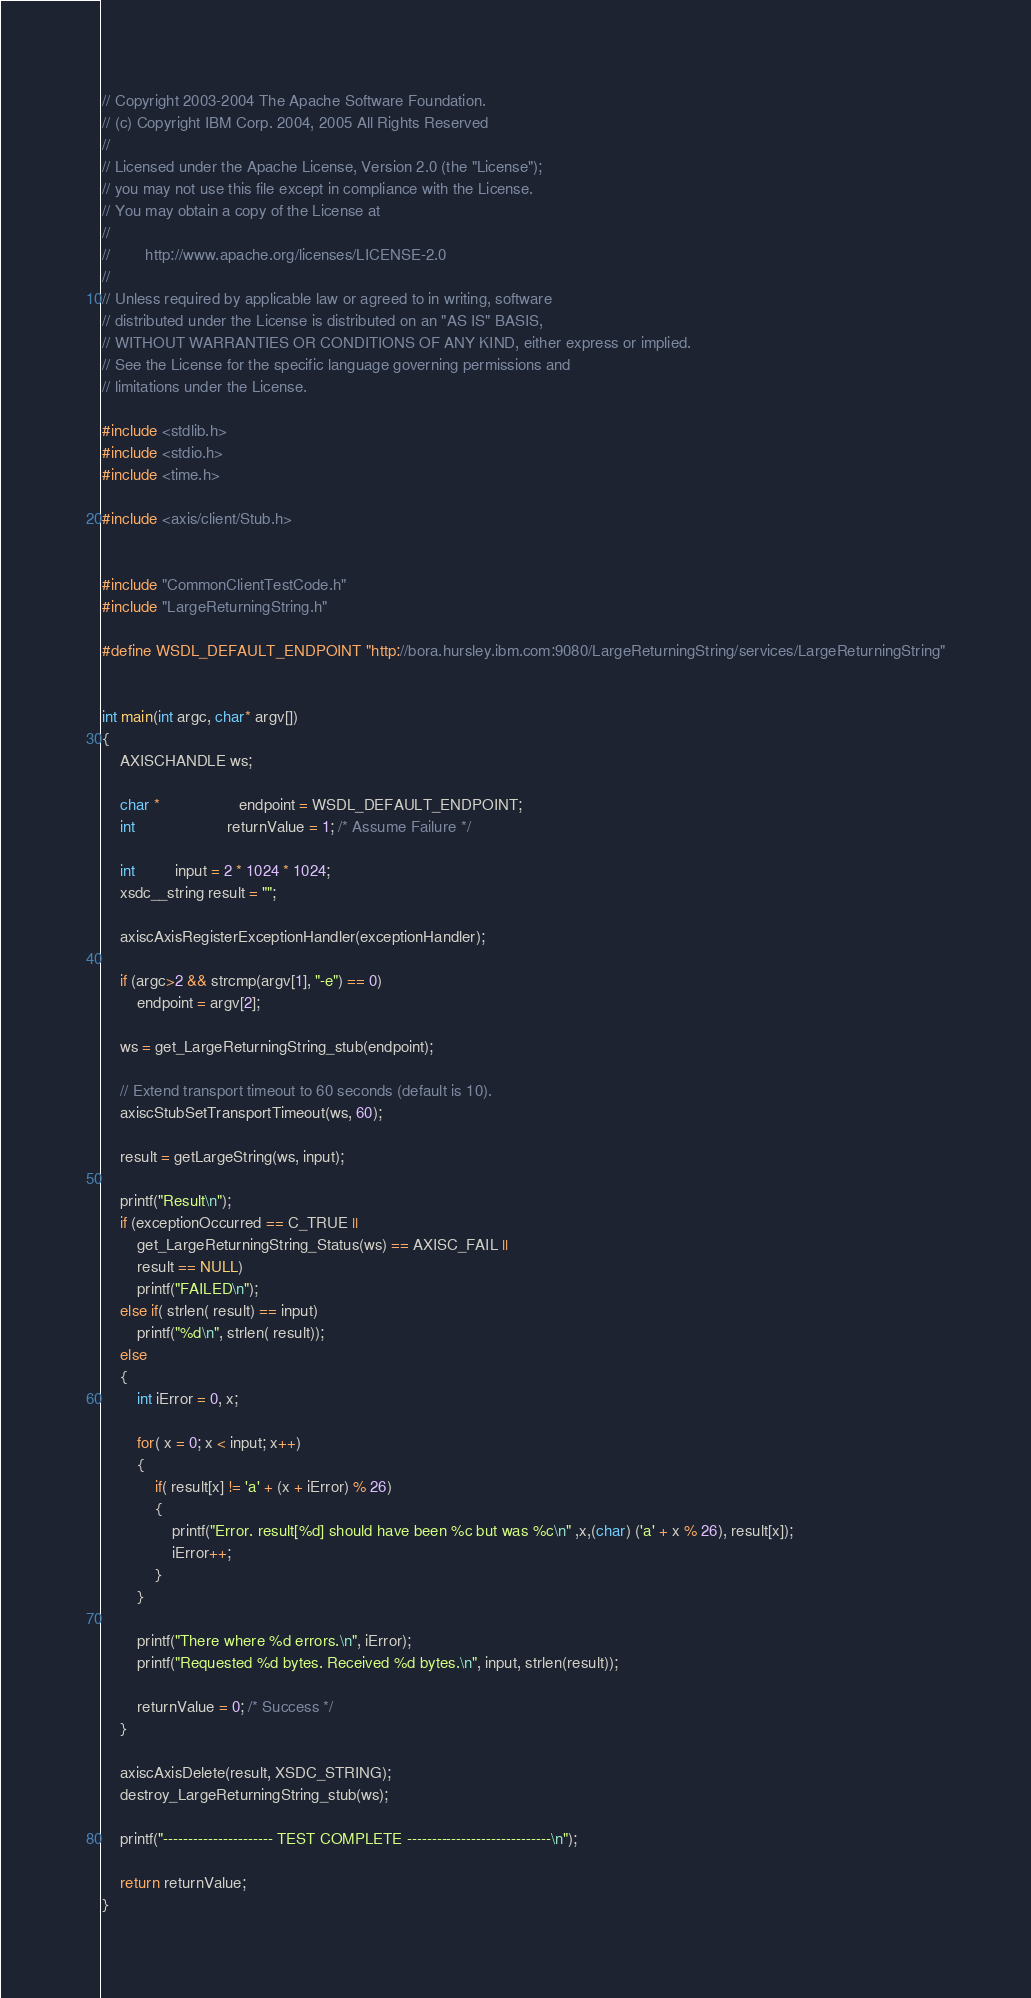<code> <loc_0><loc_0><loc_500><loc_500><_C_>// Copyright 2003-2004 The Apache Software Foundation.
// (c) Copyright IBM Corp. 2004, 2005 All Rights Reserved
// 
// Licensed under the Apache License, Version 2.0 (the "License");
// you may not use this file except in compliance with the License.
// You may obtain a copy of the License at
// 
//        http://www.apache.org/licenses/LICENSE-2.0
// 
// Unless required by applicable law or agreed to in writing, software
// distributed under the License is distributed on an "AS IS" BASIS,
// WITHOUT WARRANTIES OR CONDITIONS OF ANY KIND, either express or implied.
// See the License for the specific language governing permissions and
// limitations under the License.

#include <stdlib.h>
#include <stdio.h>
#include <time.h>

#include <axis/client/Stub.h>


#include "CommonClientTestCode.h"
#include "LargeReturningString.h"

#define WSDL_DEFAULT_ENDPOINT "http://bora.hursley.ibm.com:9080/LargeReturningString/services/LargeReturningString"


int main(int argc, char* argv[])
{
    AXISCHANDLE ws;

    char *                  endpoint = WSDL_DEFAULT_ENDPOINT;
    int                     returnValue = 1; /* Assume Failure */

    int         input = 2 * 1024 * 1024;
    xsdc__string result = "";

    axiscAxisRegisterExceptionHandler(exceptionHandler);

    if (argc>2 && strcmp(argv[1], "-e") == 0)
        endpoint = argv[2];

    ws = get_LargeReturningString_stub(endpoint);

    // Extend transport timeout to 60 seconds (default is 10).
    axiscStubSetTransportTimeout(ws, 60);

    result = getLargeString(ws, input);

    printf("Result\n");
    if (exceptionOccurred == C_TRUE ||
        get_LargeReturningString_Status(ws) == AXISC_FAIL ||
        result == NULL)
        printf("FAILED\n");
    else if( strlen( result) == input)
        printf("%d\n", strlen( result));
    else
    {
        int iError = 0, x;

        for( x = 0; x < input; x++)
        {
            if( result[x] != 'a' + (x + iError) % 26)
            {
                printf("Error. result[%d] should have been %c but was %c\n" ,x,(char) ('a' + x % 26), result[x]);
                iError++;
            }
        }

        printf("There where %d errors.\n", iError);
        printf("Requested %d bytes. Received %d bytes.\n", input, strlen(result));

        returnValue = 0; /* Success */
    }

    axiscAxisDelete(result, XSDC_STRING);
    destroy_LargeReturningString_stub(ws);

    printf("---------------------- TEST COMPLETE -----------------------------\n");

    return returnValue;
}
</code> 